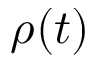Convert formula to latex. <formula><loc_0><loc_0><loc_500><loc_500>\rho ( t )</formula> 